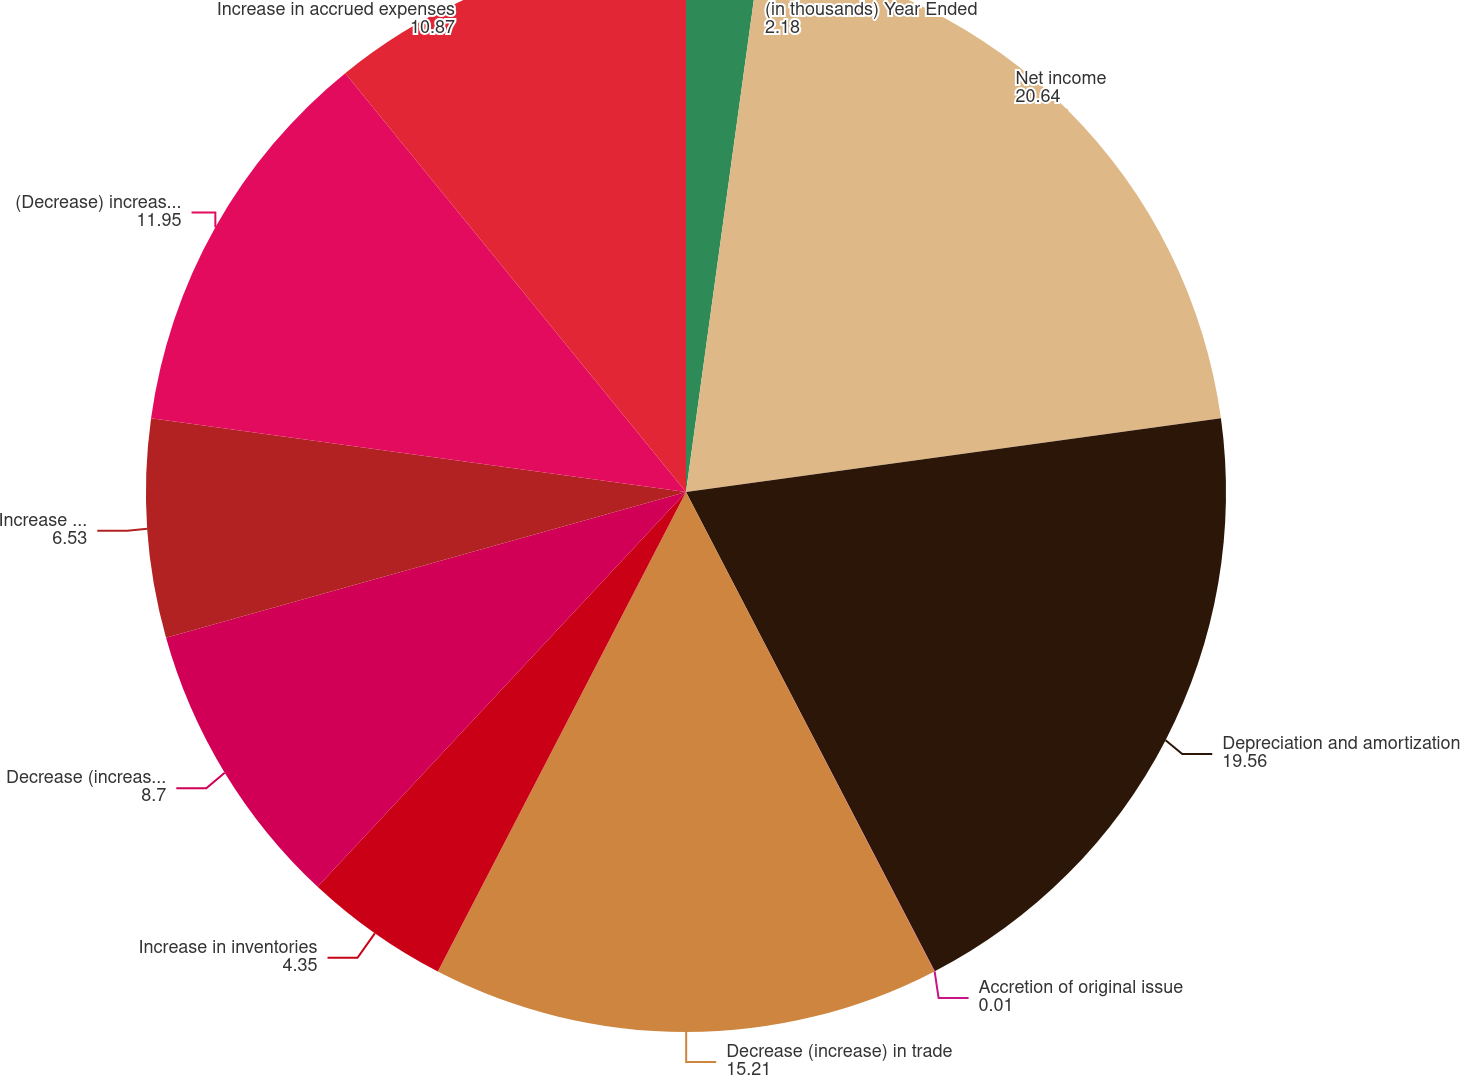Convert chart to OTSL. <chart><loc_0><loc_0><loc_500><loc_500><pie_chart><fcel>(in thousands) Year Ended<fcel>Net income<fcel>Depreciation and amortization<fcel>Accretion of original issue<fcel>Decrease (increase) in trade<fcel>Increase in inventories<fcel>Decrease (increase) in prepaid<fcel>Increase (decrease) in<fcel>(Decrease) increase in accrued<fcel>Increase in accrued expenses<nl><fcel>2.18%<fcel>20.64%<fcel>19.56%<fcel>0.01%<fcel>15.21%<fcel>4.35%<fcel>8.7%<fcel>6.53%<fcel>11.95%<fcel>10.87%<nl></chart> 